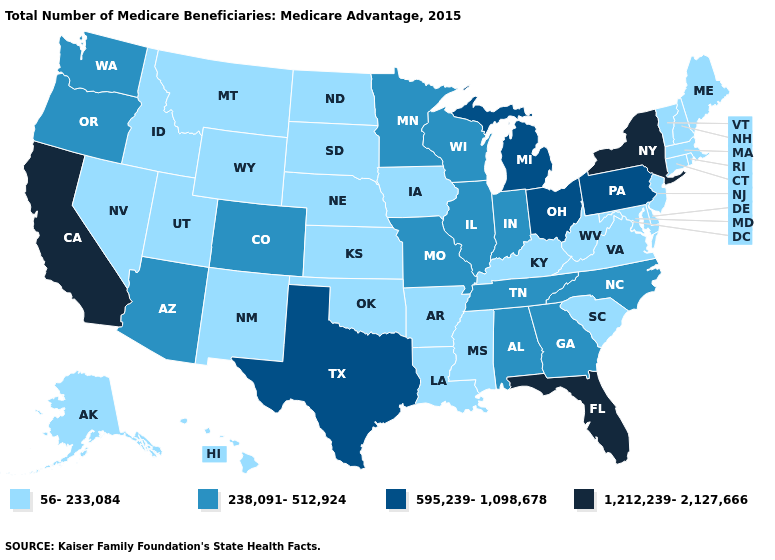Name the states that have a value in the range 56-233,084?
Concise answer only. Alaska, Arkansas, Connecticut, Delaware, Hawaii, Idaho, Iowa, Kansas, Kentucky, Louisiana, Maine, Maryland, Massachusetts, Mississippi, Montana, Nebraska, Nevada, New Hampshire, New Jersey, New Mexico, North Dakota, Oklahoma, Rhode Island, South Carolina, South Dakota, Utah, Vermont, Virginia, West Virginia, Wyoming. Does the map have missing data?
Keep it brief. No. Does Rhode Island have the highest value in the USA?
Concise answer only. No. Does Hawaii have the same value as New Mexico?
Be succinct. Yes. Among the states that border Vermont , does Massachusetts have the lowest value?
Concise answer only. Yes. Name the states that have a value in the range 238,091-512,924?
Short answer required. Alabama, Arizona, Colorado, Georgia, Illinois, Indiana, Minnesota, Missouri, North Carolina, Oregon, Tennessee, Washington, Wisconsin. Name the states that have a value in the range 595,239-1,098,678?
Quick response, please. Michigan, Ohio, Pennsylvania, Texas. What is the highest value in the USA?
Concise answer only. 1,212,239-2,127,666. Does Arkansas have the highest value in the South?
Keep it brief. No. Does Rhode Island have the highest value in the Northeast?
Write a very short answer. No. Does Iowa have a lower value than Alabama?
Write a very short answer. Yes. What is the value of Vermont?
Concise answer only. 56-233,084. What is the value of New Hampshire?
Be succinct. 56-233,084. Name the states that have a value in the range 595,239-1,098,678?
Short answer required. Michigan, Ohio, Pennsylvania, Texas. What is the value of Virginia?
Write a very short answer. 56-233,084. 